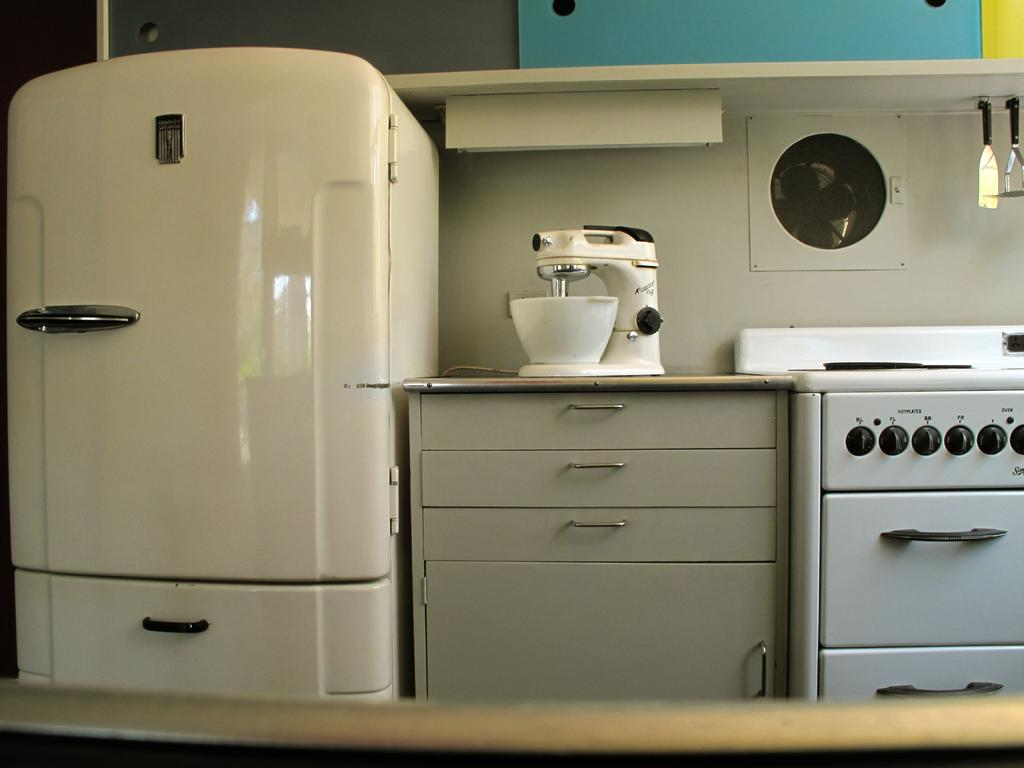What type of space is depicted in the image? The image is an inside view of a room. What can be found in the room? There are containers, cupboards, an object, a fan, a wall, and a shelf in the room. Can you describe the text visible in the room? There is text visible in the room, but the specific content is not mentioned in the facts. What is the purpose of the fan in the room? The purpose of the fan in the room is to provide air circulation. How many tomatoes are on the scale in the image? There is no scale or tomatoes present in the image. What type of slave is depicted in the image? There is no slave depicted in the image; it is an inside view of a room with various objects and features. 